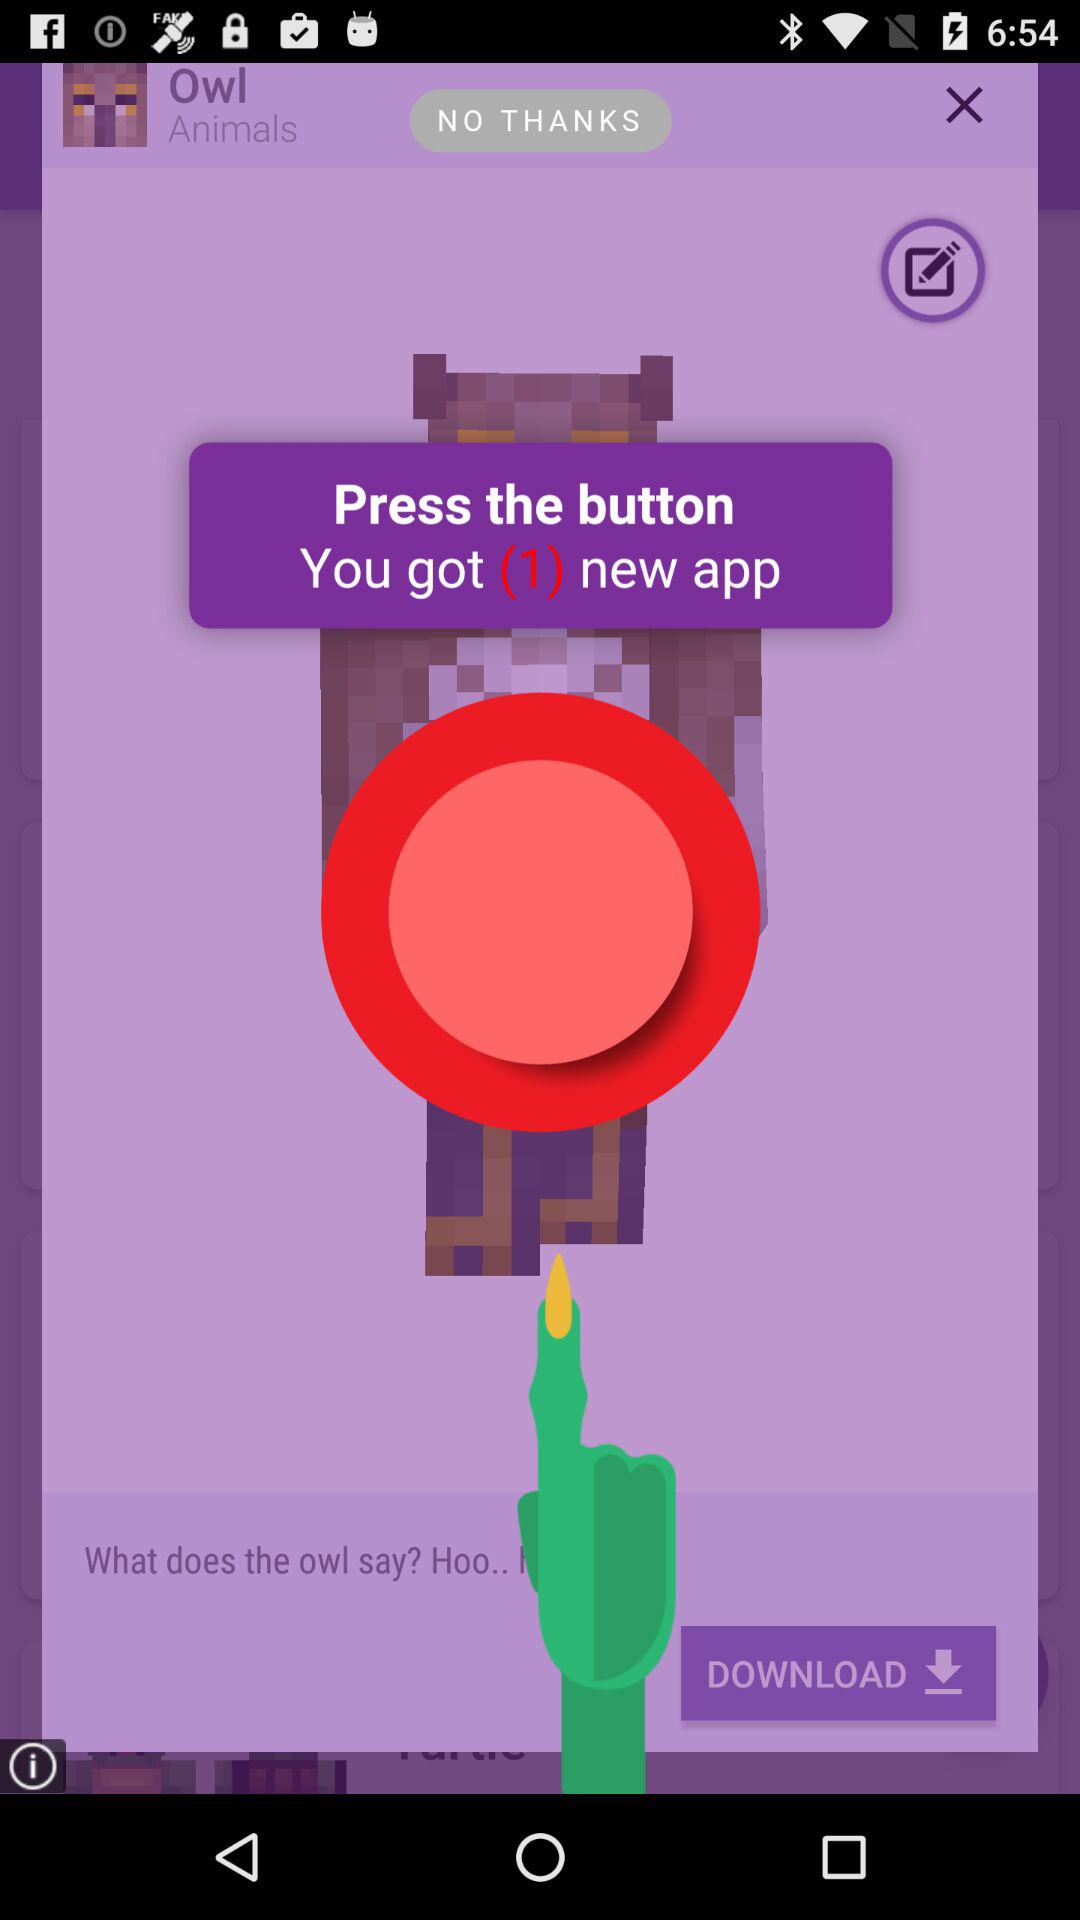How many new apps are there? There is 1 new app. 